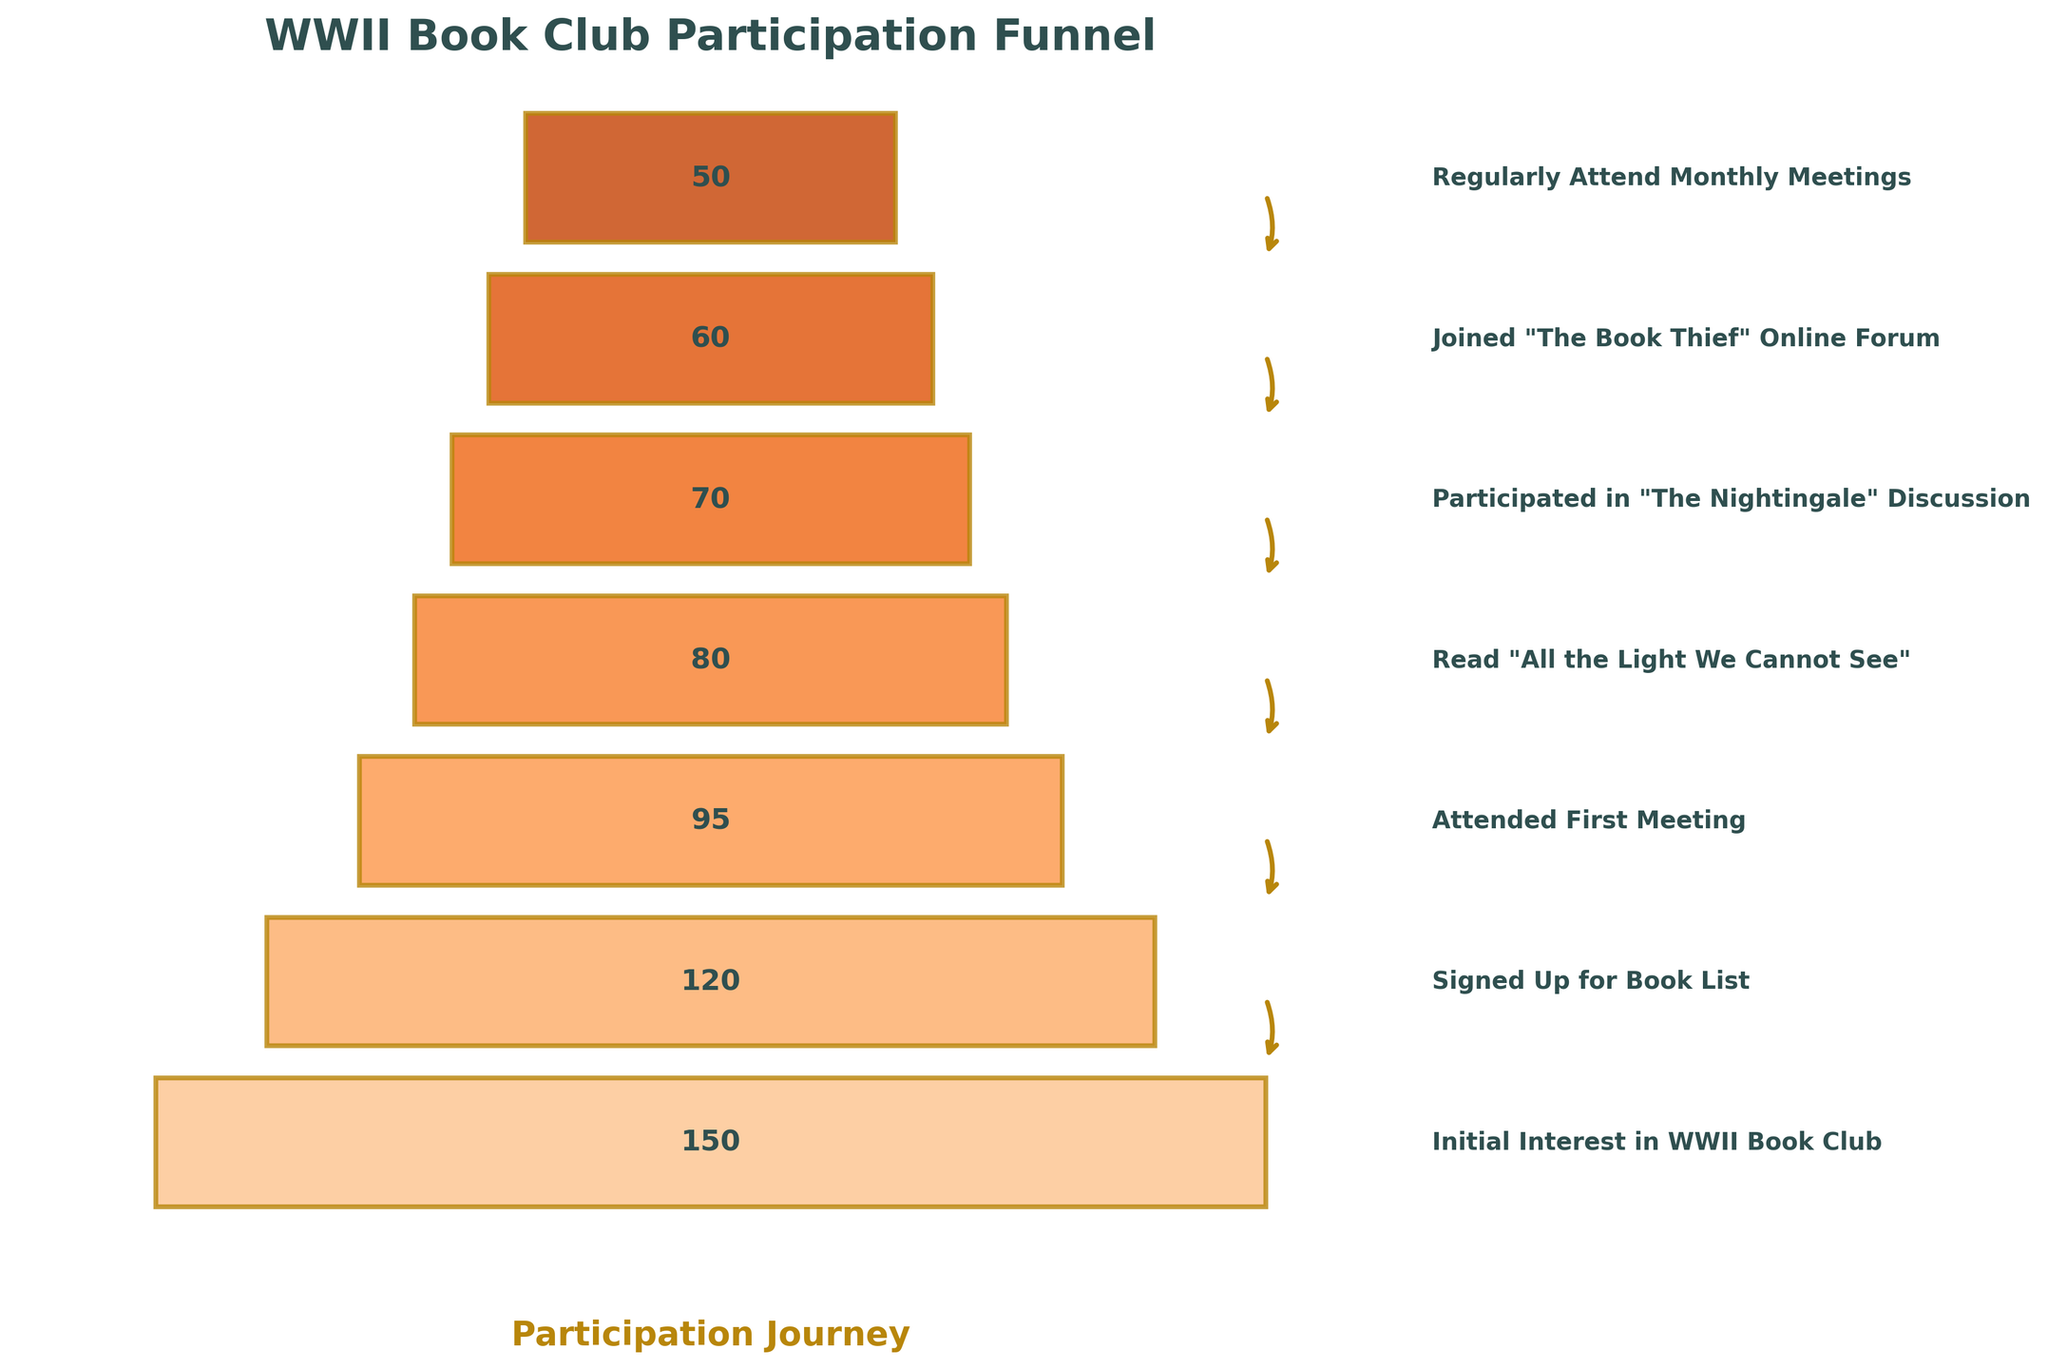What stage has the highest number of participants? The stage with the highest number of participants is the "Initial Interest in WWII Book Club". This is the first stage on the funnel chart where 150 participants showed initial interest.
Answer: Initial Interest in WWII Book Club What is the difference in participant numbers between those who attended the first meeting and those who read "All the Light We Cannot See"? To find the difference, subtract the number of participants who read "All the Light We Cannot See" (80) from those who attended the first meeting (95). 95 - 80 = 15.
Answer: 15 How many participants moved from "Initial Interest" to "Regularly Attend Monthly Meetings"? To find the total number of participants who moved from the initial interest stage to regularly attending monthly meetings, compare the numbers of these two stages. Initial Interest has 150 participants, and Regularly Attend Monthly Meetings has 50. The difference is 150 - 50 = 100 participants.
Answer: 100 Which two consecutive stages have the smallest drop in participant numbers? By observing the differences between consecutive stages:
- Initial Interest to Signed Up for Book List: 150 - 120 = 30
- Signed Up for Book List to Attended First Meeting: 120 - 95 = 25
- Attended First Meeting to Read "All the Light We Cannot See": 95 - 80 = 15
- Read "All the Light We Cannot See" to Participated in "The Nightingale" Discussion: 80 - 70 = 10
- Participated in "The Nightingale" Discussion to Joined "The Book Thief" Online Forum: 70 - 60 = 10
- Joined "The Book Thief" Online Forum to Regularly Attend Monthly Meetings: 60 - 50 = 10
The smallest drop is between "Read 'All the Light We Cannot See'" and "Participated in 'The Nightingale' Discussion" with a drop of 10 participants.
Answer: Read "All the Light We Cannot See" to Participated in "The Nightingale" Discussion What percentage of participants who signed up for the book list went on to regularly attend monthly meetings? First, find the number of participants who signed up for the book list, which is 120. Then, find how many of these went on to regularly attend monthly meetings, which is 50. The percentage is calculated as (50 / 120) * 100 ≈ 41.67%.
Answer: 41.67% Between which stages did the number of participants drop by 25? By checking the differences between consecutive stages:
- Initial Interest to Signed Up for Book List: 150 - 120 = 30
- Signed Up for Book List to Attended First Meeting: 120 - 95 = 25
- Attended First Meeting to Read "All the Light We Cannot See": 95 - 80 = 15
- Read "All the Light We Cannot See" to Participated in "The Nightingale" Discussion: 80 - 70 = 10
- Participated in "The Nightingale" Discussion to Joined "The Book Thief" Online Forum: 70 - 60 = 10
- Joined "The Book Thief" Online Forum to Regularly Attend Monthly Meetings: 60 - 50 = 10
The number of participants dropped by 25 between the "Signed Up for Book List" stage and the "Attended First Meeting" stage.
Answer: Signed Up for Book List to Attended First Meeting How many stages are there in the funnel chart? The funnel chart visually represents different stages of participation. Counting each stage from the top to the bottom gives us a total of 7 stages.
Answer: 7 